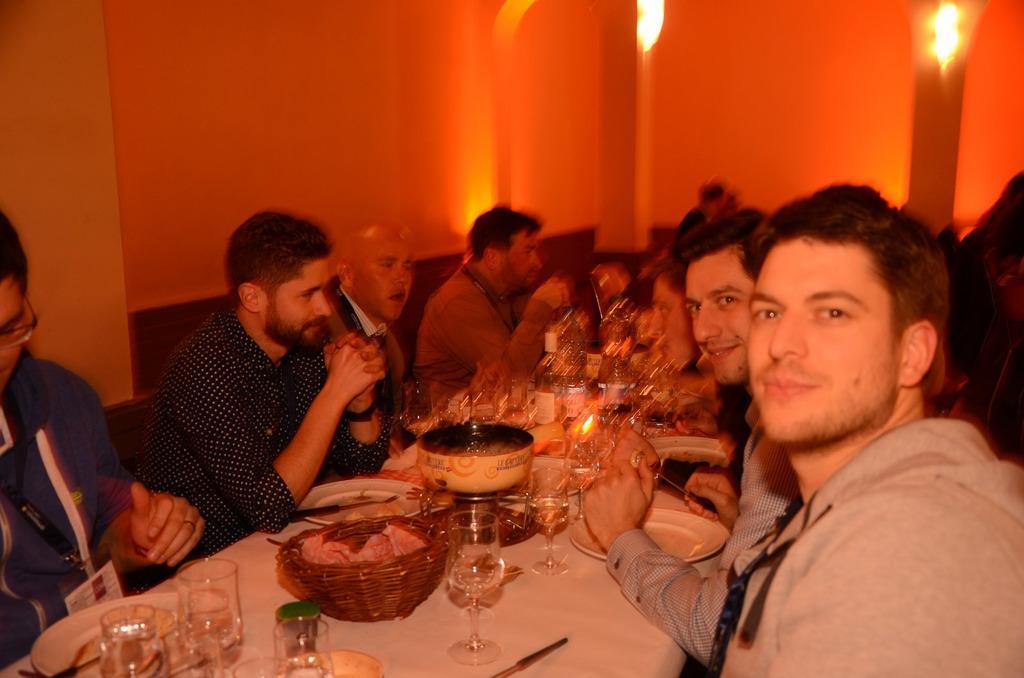Describe this image in one or two sentences. In this picture we observe many people sitting on the table, and there is a white color cloth on the table above which food and beverages are on it and the glasses are in good design. In the background there is a wall with red color lights on it. 